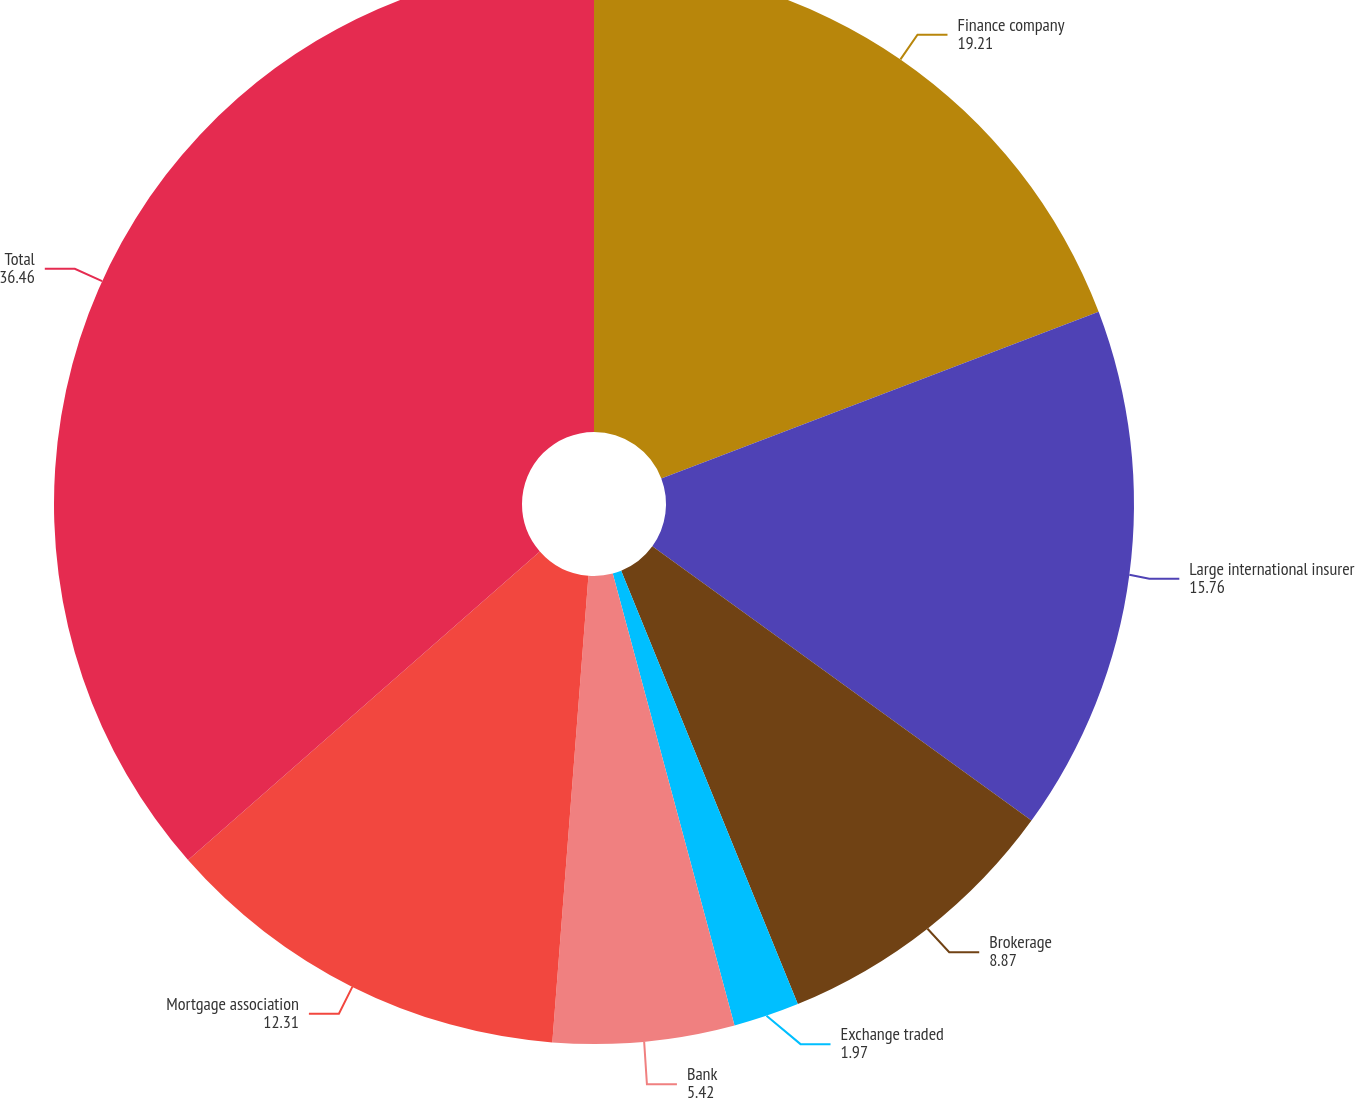<chart> <loc_0><loc_0><loc_500><loc_500><pie_chart><fcel>Finance company<fcel>Large international insurer<fcel>Brokerage<fcel>Exchange traded<fcel>Bank<fcel>Mortgage association<fcel>Total<nl><fcel>19.21%<fcel>15.76%<fcel>8.87%<fcel>1.97%<fcel>5.42%<fcel>12.31%<fcel>36.46%<nl></chart> 